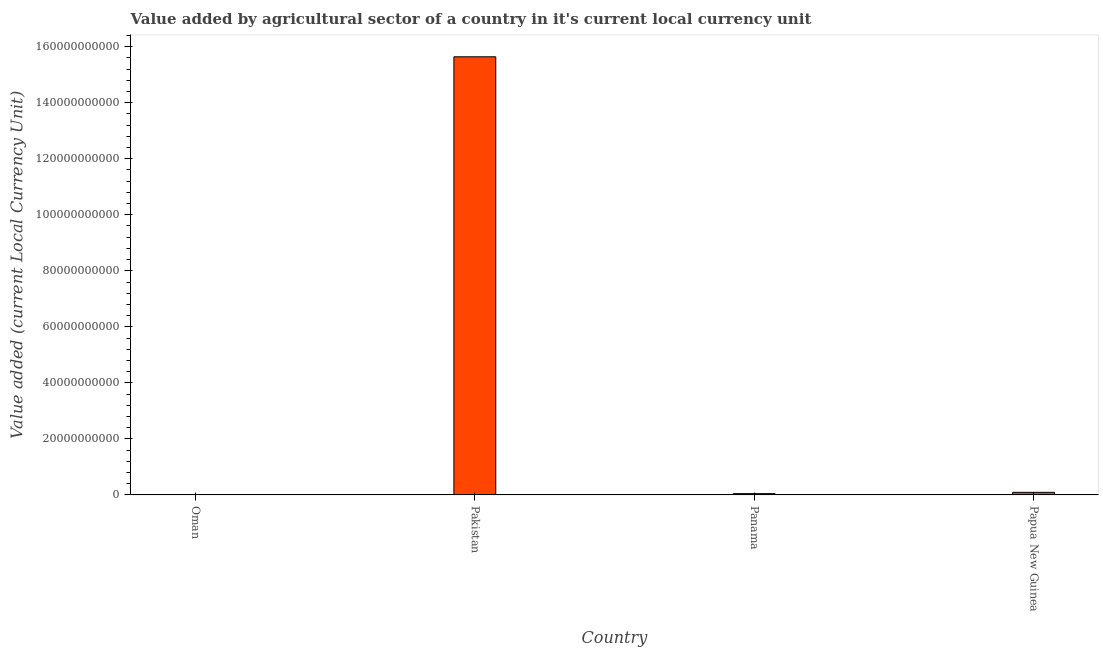Does the graph contain any zero values?
Keep it short and to the point. No. Does the graph contain grids?
Keep it short and to the point. No. What is the title of the graph?
Offer a terse response. Value added by agricultural sector of a country in it's current local currency unit. What is the label or title of the X-axis?
Ensure brevity in your answer.  Country. What is the label or title of the Y-axis?
Provide a short and direct response. Value added (current Local Currency Unit). What is the value added by agriculture sector in Papua New Guinea?
Keep it short and to the point. 9.24e+08. Across all countries, what is the maximum value added by agriculture sector?
Keep it short and to the point. 1.56e+11. Across all countries, what is the minimum value added by agriculture sector?
Offer a terse response. 1.24e+08. In which country was the value added by agriculture sector minimum?
Your response must be concise. Oman. What is the sum of the value added by agriculture sector?
Ensure brevity in your answer.  1.58e+11. What is the difference between the value added by agriculture sector in Oman and Papua New Guinea?
Ensure brevity in your answer.  -8.00e+08. What is the average value added by agriculture sector per country?
Your answer should be very brief. 3.95e+1. What is the median value added by agriculture sector?
Ensure brevity in your answer.  6.90e+08. In how many countries, is the value added by agriculture sector greater than 76000000000 LCU?
Your response must be concise. 1. What is the ratio of the value added by agriculture sector in Oman to that in Pakistan?
Offer a very short reply. 0. What is the difference between the highest and the second highest value added by agriculture sector?
Make the answer very short. 1.55e+11. What is the difference between the highest and the lowest value added by agriculture sector?
Your response must be concise. 1.56e+11. How many bars are there?
Your answer should be very brief. 4. Are all the bars in the graph horizontal?
Offer a terse response. No. How many countries are there in the graph?
Your answer should be very brief. 4. What is the difference between two consecutive major ticks on the Y-axis?
Offer a terse response. 2.00e+1. Are the values on the major ticks of Y-axis written in scientific E-notation?
Your answer should be very brief. No. What is the Value added (current Local Currency Unit) in Oman?
Your answer should be compact. 1.24e+08. What is the Value added (current Local Currency Unit) of Pakistan?
Your response must be concise. 1.56e+11. What is the Value added (current Local Currency Unit) in Panama?
Give a very brief answer. 4.56e+08. What is the Value added (current Local Currency Unit) in Papua New Guinea?
Make the answer very short. 9.24e+08. What is the difference between the Value added (current Local Currency Unit) in Oman and Pakistan?
Keep it short and to the point. -1.56e+11. What is the difference between the Value added (current Local Currency Unit) in Oman and Panama?
Offer a very short reply. -3.32e+08. What is the difference between the Value added (current Local Currency Unit) in Oman and Papua New Guinea?
Your response must be concise. -8.00e+08. What is the difference between the Value added (current Local Currency Unit) in Pakistan and Panama?
Offer a terse response. 1.56e+11. What is the difference between the Value added (current Local Currency Unit) in Pakistan and Papua New Guinea?
Provide a short and direct response. 1.55e+11. What is the difference between the Value added (current Local Currency Unit) in Panama and Papua New Guinea?
Offer a terse response. -4.68e+08. What is the ratio of the Value added (current Local Currency Unit) in Oman to that in Panama?
Your answer should be very brief. 0.27. What is the ratio of the Value added (current Local Currency Unit) in Oman to that in Papua New Guinea?
Your answer should be compact. 0.13. What is the ratio of the Value added (current Local Currency Unit) in Pakistan to that in Panama?
Ensure brevity in your answer.  343.21. What is the ratio of the Value added (current Local Currency Unit) in Pakistan to that in Papua New Guinea?
Offer a very short reply. 169.26. What is the ratio of the Value added (current Local Currency Unit) in Panama to that in Papua New Guinea?
Offer a terse response. 0.49. 